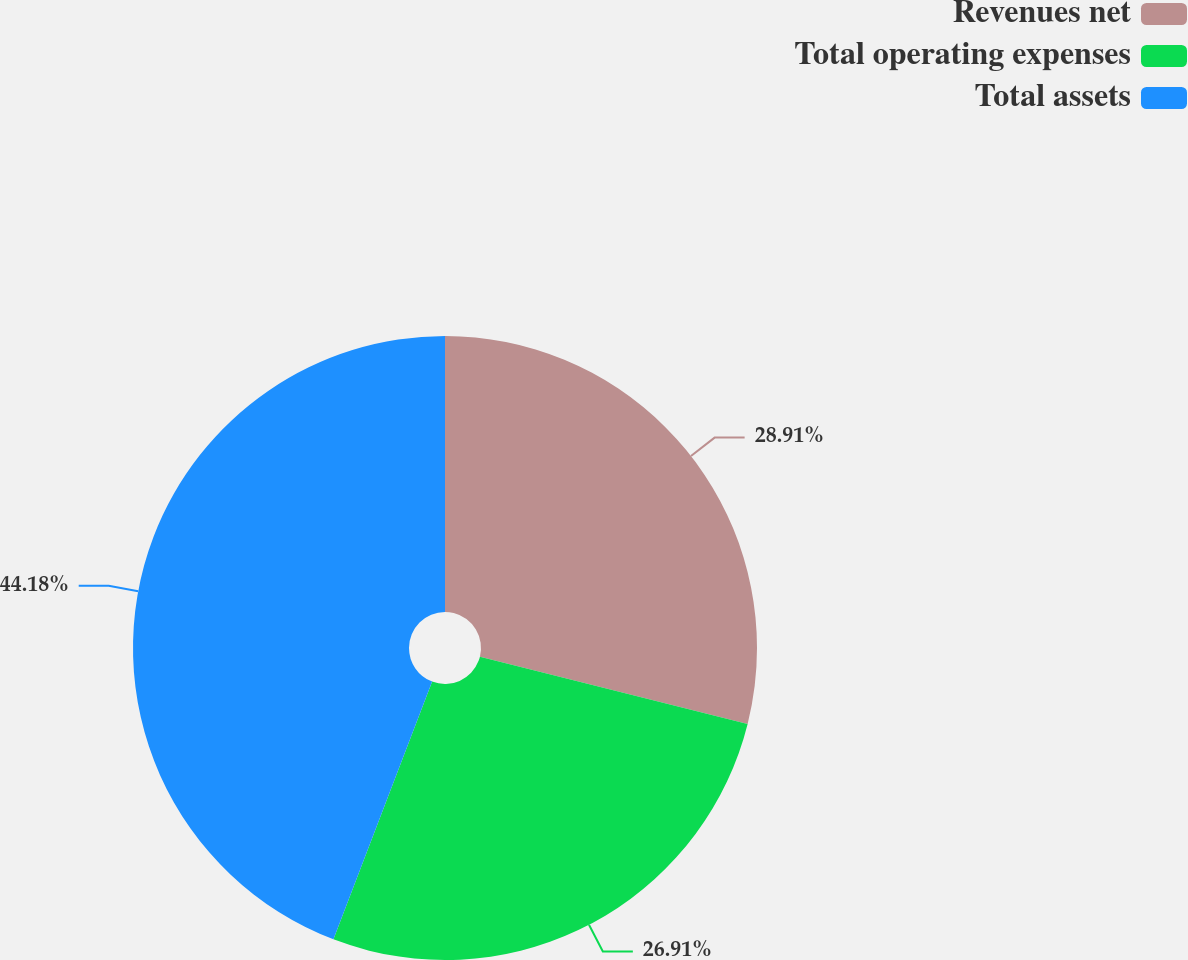<chart> <loc_0><loc_0><loc_500><loc_500><pie_chart><fcel>Revenues net<fcel>Total operating expenses<fcel>Total assets<nl><fcel>28.91%<fcel>26.91%<fcel>44.18%<nl></chart> 